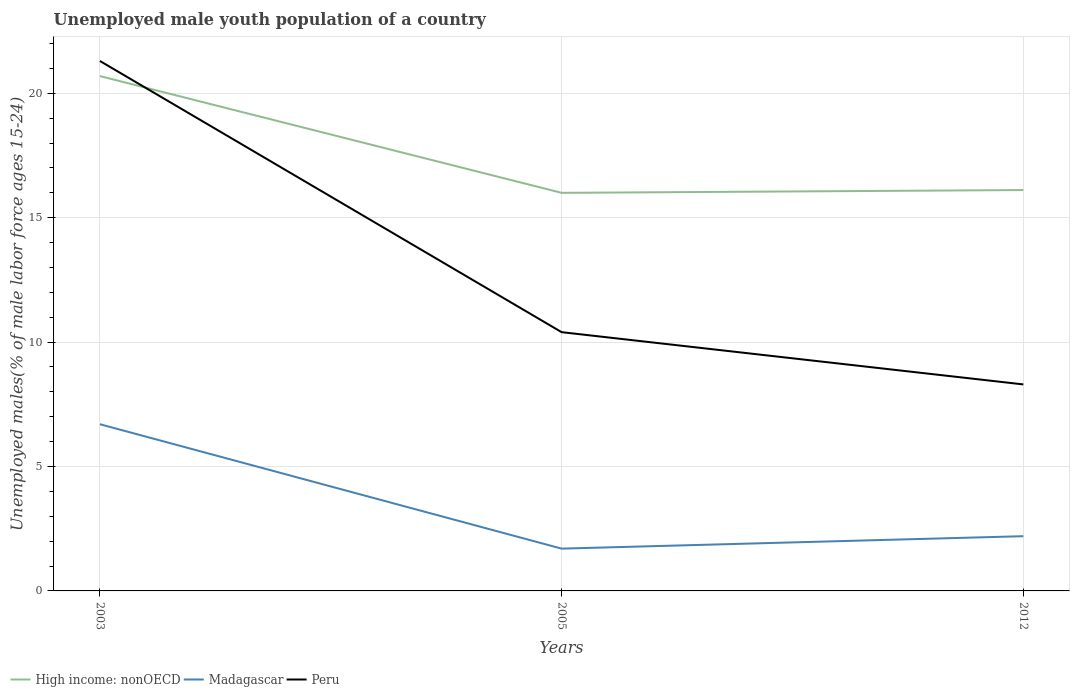How many different coloured lines are there?
Ensure brevity in your answer.  3. Does the line corresponding to Madagascar intersect with the line corresponding to High income: nonOECD?
Your response must be concise. No. Is the number of lines equal to the number of legend labels?
Make the answer very short. Yes. Across all years, what is the maximum percentage of unemployed male youth population in High income: nonOECD?
Offer a terse response. 16. In which year was the percentage of unemployed male youth population in High income: nonOECD maximum?
Offer a terse response. 2005. What is the total percentage of unemployed male youth population in High income: nonOECD in the graph?
Provide a short and direct response. 4.58. What is the difference between the highest and the second highest percentage of unemployed male youth population in Peru?
Give a very brief answer. 13. What is the difference between two consecutive major ticks on the Y-axis?
Your answer should be very brief. 5. Are the values on the major ticks of Y-axis written in scientific E-notation?
Offer a very short reply. No. Does the graph contain any zero values?
Provide a short and direct response. No. What is the title of the graph?
Provide a succinct answer. Unemployed male youth population of a country. Does "Spain" appear as one of the legend labels in the graph?
Keep it short and to the point. No. What is the label or title of the Y-axis?
Provide a succinct answer. Unemployed males(% of male labor force ages 15-24). What is the Unemployed males(% of male labor force ages 15-24) of High income: nonOECD in 2003?
Make the answer very short. 20.69. What is the Unemployed males(% of male labor force ages 15-24) of Madagascar in 2003?
Your response must be concise. 6.7. What is the Unemployed males(% of male labor force ages 15-24) of Peru in 2003?
Provide a short and direct response. 21.3. What is the Unemployed males(% of male labor force ages 15-24) in High income: nonOECD in 2005?
Offer a terse response. 16. What is the Unemployed males(% of male labor force ages 15-24) in Madagascar in 2005?
Give a very brief answer. 1.7. What is the Unemployed males(% of male labor force ages 15-24) in Peru in 2005?
Your response must be concise. 10.4. What is the Unemployed males(% of male labor force ages 15-24) in High income: nonOECD in 2012?
Provide a short and direct response. 16.11. What is the Unemployed males(% of male labor force ages 15-24) of Madagascar in 2012?
Your answer should be very brief. 2.2. What is the Unemployed males(% of male labor force ages 15-24) of Peru in 2012?
Your response must be concise. 8.3. Across all years, what is the maximum Unemployed males(% of male labor force ages 15-24) of High income: nonOECD?
Your response must be concise. 20.69. Across all years, what is the maximum Unemployed males(% of male labor force ages 15-24) of Madagascar?
Your answer should be compact. 6.7. Across all years, what is the maximum Unemployed males(% of male labor force ages 15-24) of Peru?
Your response must be concise. 21.3. Across all years, what is the minimum Unemployed males(% of male labor force ages 15-24) of High income: nonOECD?
Offer a very short reply. 16. Across all years, what is the minimum Unemployed males(% of male labor force ages 15-24) in Madagascar?
Ensure brevity in your answer.  1.7. Across all years, what is the minimum Unemployed males(% of male labor force ages 15-24) in Peru?
Provide a short and direct response. 8.3. What is the total Unemployed males(% of male labor force ages 15-24) in High income: nonOECD in the graph?
Offer a very short reply. 52.8. What is the total Unemployed males(% of male labor force ages 15-24) in Madagascar in the graph?
Your response must be concise. 10.6. What is the total Unemployed males(% of male labor force ages 15-24) of Peru in the graph?
Offer a terse response. 40. What is the difference between the Unemployed males(% of male labor force ages 15-24) in High income: nonOECD in 2003 and that in 2005?
Your response must be concise. 4.69. What is the difference between the Unemployed males(% of male labor force ages 15-24) in Peru in 2003 and that in 2005?
Provide a succinct answer. 10.9. What is the difference between the Unemployed males(% of male labor force ages 15-24) in High income: nonOECD in 2003 and that in 2012?
Provide a succinct answer. 4.58. What is the difference between the Unemployed males(% of male labor force ages 15-24) in Peru in 2003 and that in 2012?
Make the answer very short. 13. What is the difference between the Unemployed males(% of male labor force ages 15-24) of High income: nonOECD in 2005 and that in 2012?
Keep it short and to the point. -0.11. What is the difference between the Unemployed males(% of male labor force ages 15-24) in Madagascar in 2005 and that in 2012?
Your response must be concise. -0.5. What is the difference between the Unemployed males(% of male labor force ages 15-24) in Peru in 2005 and that in 2012?
Your response must be concise. 2.1. What is the difference between the Unemployed males(% of male labor force ages 15-24) in High income: nonOECD in 2003 and the Unemployed males(% of male labor force ages 15-24) in Madagascar in 2005?
Your answer should be very brief. 18.99. What is the difference between the Unemployed males(% of male labor force ages 15-24) of High income: nonOECD in 2003 and the Unemployed males(% of male labor force ages 15-24) of Peru in 2005?
Keep it short and to the point. 10.29. What is the difference between the Unemployed males(% of male labor force ages 15-24) in High income: nonOECD in 2003 and the Unemployed males(% of male labor force ages 15-24) in Madagascar in 2012?
Your answer should be compact. 18.49. What is the difference between the Unemployed males(% of male labor force ages 15-24) in High income: nonOECD in 2003 and the Unemployed males(% of male labor force ages 15-24) in Peru in 2012?
Ensure brevity in your answer.  12.39. What is the difference between the Unemployed males(% of male labor force ages 15-24) in High income: nonOECD in 2005 and the Unemployed males(% of male labor force ages 15-24) in Madagascar in 2012?
Your response must be concise. 13.8. What is the difference between the Unemployed males(% of male labor force ages 15-24) in High income: nonOECD in 2005 and the Unemployed males(% of male labor force ages 15-24) in Peru in 2012?
Keep it short and to the point. 7.7. What is the average Unemployed males(% of male labor force ages 15-24) of High income: nonOECD per year?
Keep it short and to the point. 17.6. What is the average Unemployed males(% of male labor force ages 15-24) of Madagascar per year?
Your response must be concise. 3.53. What is the average Unemployed males(% of male labor force ages 15-24) of Peru per year?
Provide a short and direct response. 13.33. In the year 2003, what is the difference between the Unemployed males(% of male labor force ages 15-24) in High income: nonOECD and Unemployed males(% of male labor force ages 15-24) in Madagascar?
Keep it short and to the point. 13.99. In the year 2003, what is the difference between the Unemployed males(% of male labor force ages 15-24) of High income: nonOECD and Unemployed males(% of male labor force ages 15-24) of Peru?
Provide a succinct answer. -0.61. In the year 2003, what is the difference between the Unemployed males(% of male labor force ages 15-24) of Madagascar and Unemployed males(% of male labor force ages 15-24) of Peru?
Your answer should be compact. -14.6. In the year 2005, what is the difference between the Unemployed males(% of male labor force ages 15-24) of High income: nonOECD and Unemployed males(% of male labor force ages 15-24) of Madagascar?
Make the answer very short. 14.3. In the year 2005, what is the difference between the Unemployed males(% of male labor force ages 15-24) of High income: nonOECD and Unemployed males(% of male labor force ages 15-24) of Peru?
Your answer should be compact. 5.6. In the year 2005, what is the difference between the Unemployed males(% of male labor force ages 15-24) of Madagascar and Unemployed males(% of male labor force ages 15-24) of Peru?
Provide a succinct answer. -8.7. In the year 2012, what is the difference between the Unemployed males(% of male labor force ages 15-24) in High income: nonOECD and Unemployed males(% of male labor force ages 15-24) in Madagascar?
Keep it short and to the point. 13.91. In the year 2012, what is the difference between the Unemployed males(% of male labor force ages 15-24) in High income: nonOECD and Unemployed males(% of male labor force ages 15-24) in Peru?
Provide a succinct answer. 7.81. In the year 2012, what is the difference between the Unemployed males(% of male labor force ages 15-24) in Madagascar and Unemployed males(% of male labor force ages 15-24) in Peru?
Your answer should be compact. -6.1. What is the ratio of the Unemployed males(% of male labor force ages 15-24) of High income: nonOECD in 2003 to that in 2005?
Offer a very short reply. 1.29. What is the ratio of the Unemployed males(% of male labor force ages 15-24) of Madagascar in 2003 to that in 2005?
Keep it short and to the point. 3.94. What is the ratio of the Unemployed males(% of male labor force ages 15-24) of Peru in 2003 to that in 2005?
Give a very brief answer. 2.05. What is the ratio of the Unemployed males(% of male labor force ages 15-24) of High income: nonOECD in 2003 to that in 2012?
Ensure brevity in your answer.  1.28. What is the ratio of the Unemployed males(% of male labor force ages 15-24) of Madagascar in 2003 to that in 2012?
Give a very brief answer. 3.05. What is the ratio of the Unemployed males(% of male labor force ages 15-24) in Peru in 2003 to that in 2012?
Offer a very short reply. 2.57. What is the ratio of the Unemployed males(% of male labor force ages 15-24) of Madagascar in 2005 to that in 2012?
Your response must be concise. 0.77. What is the ratio of the Unemployed males(% of male labor force ages 15-24) of Peru in 2005 to that in 2012?
Offer a terse response. 1.25. What is the difference between the highest and the second highest Unemployed males(% of male labor force ages 15-24) of High income: nonOECD?
Make the answer very short. 4.58. What is the difference between the highest and the second highest Unemployed males(% of male labor force ages 15-24) of Madagascar?
Your answer should be very brief. 4.5. What is the difference between the highest and the lowest Unemployed males(% of male labor force ages 15-24) of High income: nonOECD?
Provide a succinct answer. 4.69. What is the difference between the highest and the lowest Unemployed males(% of male labor force ages 15-24) of Peru?
Make the answer very short. 13. 